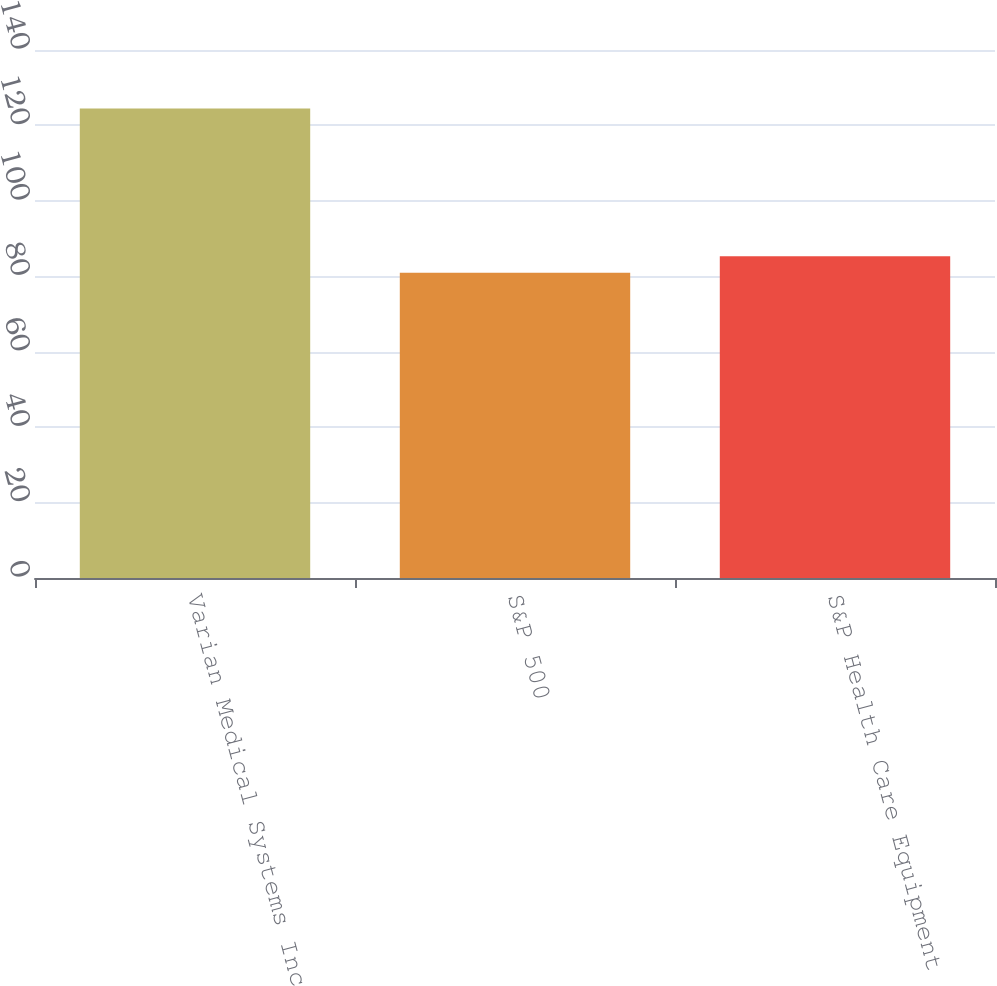<chart> <loc_0><loc_0><loc_500><loc_500><bar_chart><fcel>Varian Medical Systems Inc<fcel>S&P 500<fcel>S&P Health Care Equipment<nl><fcel>124.52<fcel>80.93<fcel>85.29<nl></chart> 